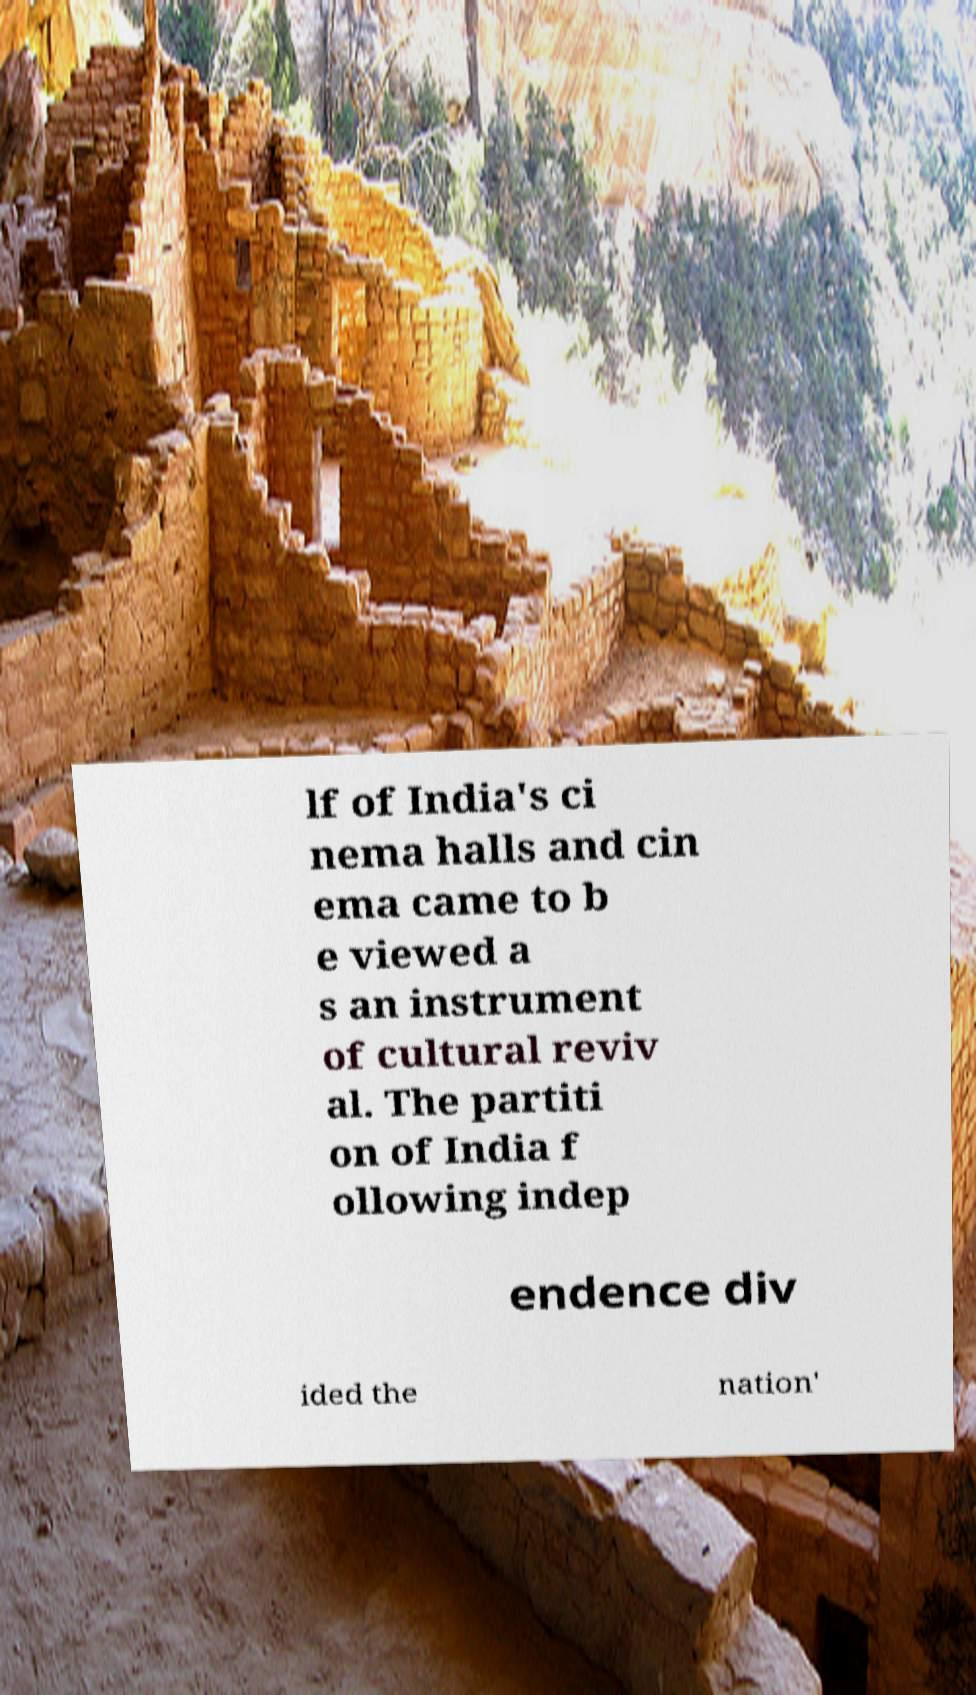For documentation purposes, I need the text within this image transcribed. Could you provide that? lf of India's ci nema halls and cin ema came to b e viewed a s an instrument of cultural reviv al. The partiti on of India f ollowing indep endence div ided the nation' 